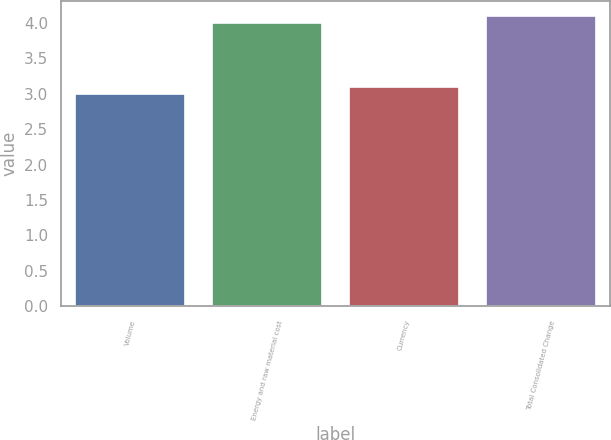Convert chart to OTSL. <chart><loc_0><loc_0><loc_500><loc_500><bar_chart><fcel>Volume<fcel>Energy and raw material cost<fcel>Currency<fcel>Total Consolidated Change<nl><fcel>3<fcel>4<fcel>3.1<fcel>4.1<nl></chart> 